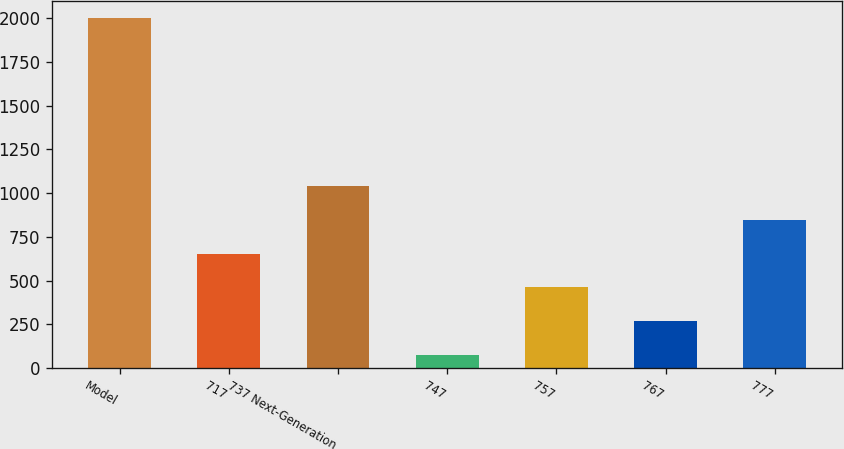Convert chart to OTSL. <chart><loc_0><loc_0><loc_500><loc_500><bar_chart><fcel>Model<fcel>717<fcel>737 Next-Generation<fcel>747<fcel>757<fcel>767<fcel>777<nl><fcel>2000<fcel>653.9<fcel>1038.5<fcel>77<fcel>461.6<fcel>269.3<fcel>846.2<nl></chart> 